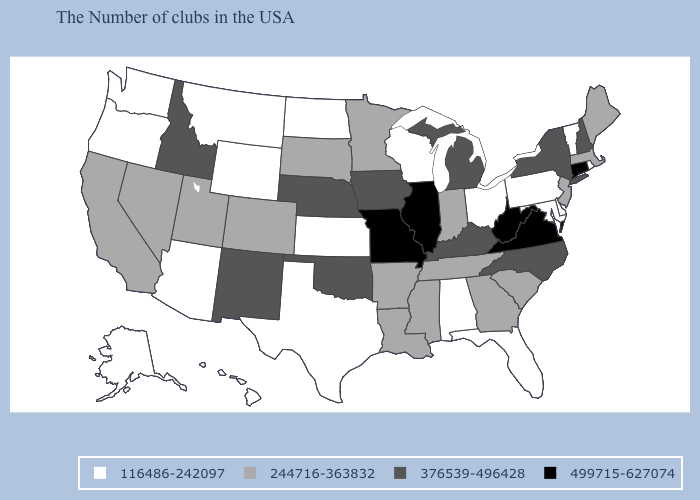What is the value of Minnesota?
Be succinct. 244716-363832. Does Montana have the same value as Pennsylvania?
Quick response, please. Yes. Does the first symbol in the legend represent the smallest category?
Keep it brief. Yes. Name the states that have a value in the range 499715-627074?
Concise answer only. Connecticut, Virginia, West Virginia, Illinois, Missouri. Does Texas have the highest value in the USA?
Short answer required. No. Name the states that have a value in the range 376539-496428?
Keep it brief. New Hampshire, New York, North Carolina, Michigan, Kentucky, Iowa, Nebraska, Oklahoma, New Mexico, Idaho. What is the highest value in the USA?
Quick response, please. 499715-627074. What is the highest value in states that border Louisiana?
Answer briefly. 244716-363832. How many symbols are there in the legend?
Give a very brief answer. 4. Name the states that have a value in the range 499715-627074?
Quick response, please. Connecticut, Virginia, West Virginia, Illinois, Missouri. Does Illinois have the highest value in the USA?
Concise answer only. Yes. Does South Carolina have the lowest value in the USA?
Write a very short answer. No. Does Texas have the lowest value in the USA?
Write a very short answer. Yes. What is the value of Kentucky?
Answer briefly. 376539-496428. Does the map have missing data?
Answer briefly. No. 